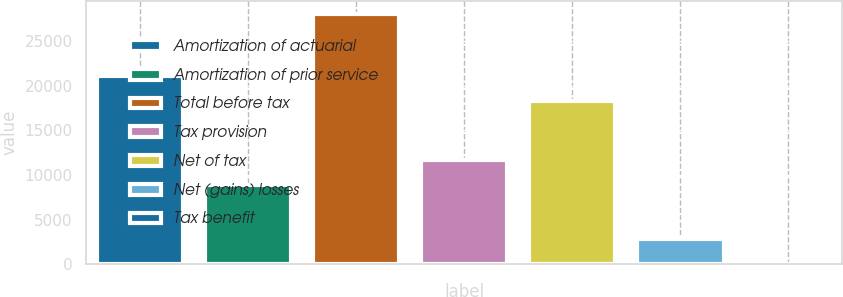Convert chart to OTSL. <chart><loc_0><loc_0><loc_500><loc_500><bar_chart><fcel>Amortization of actuarial<fcel>Amortization of prior service<fcel>Total before tax<fcel>Tax provision<fcel>Net of tax<fcel>Net (gains) losses<fcel>Tax benefit<nl><fcel>21078.8<fcel>8834<fcel>28084<fcel>11637.8<fcel>18275<fcel>2849.8<fcel>46<nl></chart> 